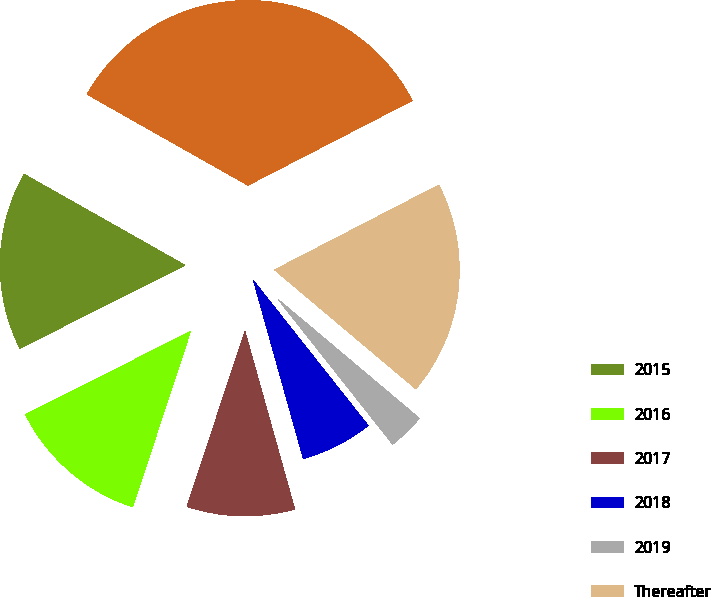Convert chart. <chart><loc_0><loc_0><loc_500><loc_500><pie_chart><fcel>2015<fcel>2016<fcel>2017<fcel>2018<fcel>2019<fcel>Thereafter<fcel>Total<nl><fcel>15.61%<fcel>12.51%<fcel>9.41%<fcel>6.31%<fcel>3.21%<fcel>18.72%<fcel>34.22%<nl></chart> 